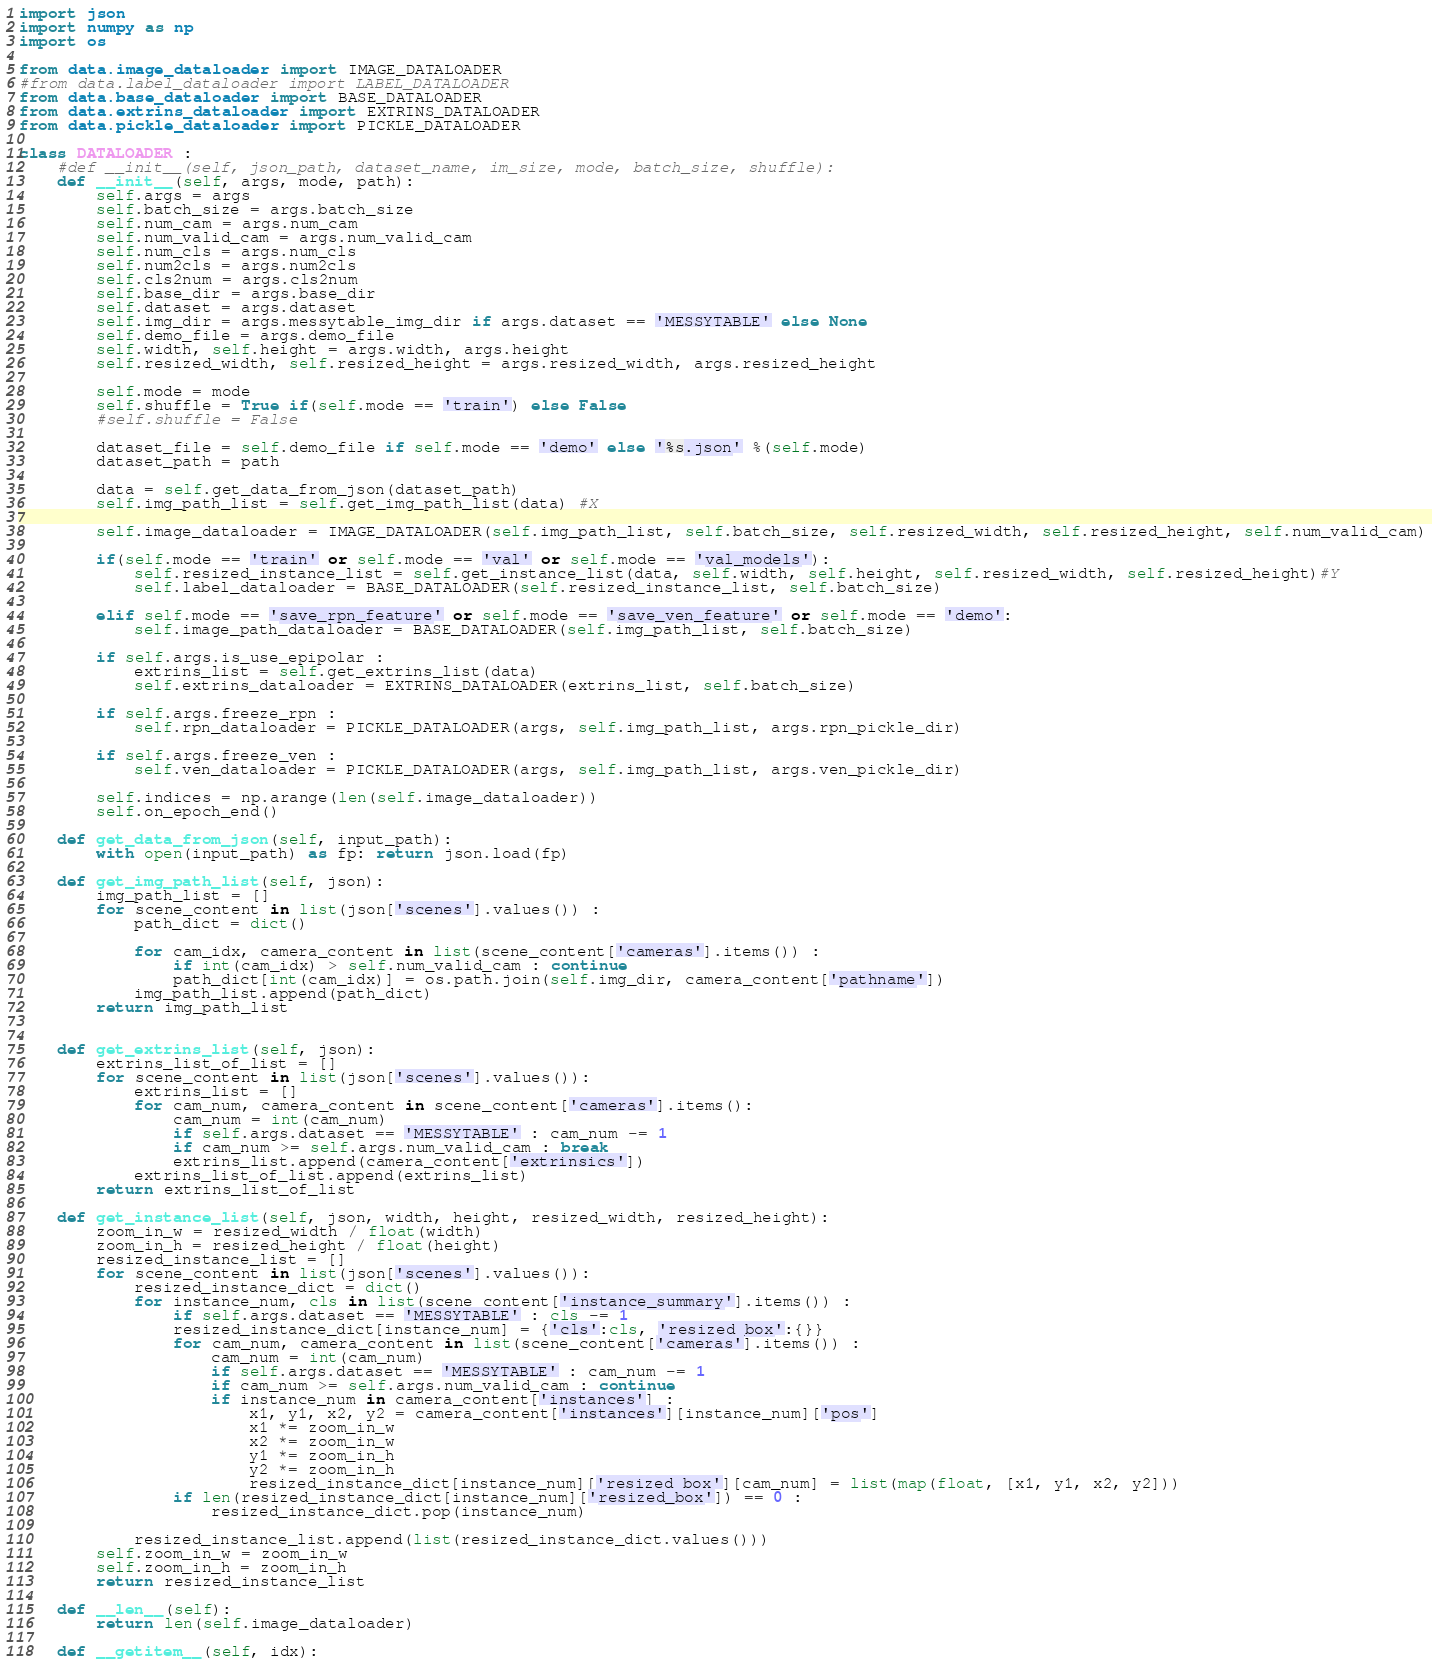<code> <loc_0><loc_0><loc_500><loc_500><_Python_>import json
import numpy as np
import os

from data.image_dataloader import IMAGE_DATALOADER
#from data.label_dataloader import LABEL_DATALOADER
from data.base_dataloader import BASE_DATALOADER
from data.extrins_dataloader import EXTRINS_DATALOADER
from data.pickle_dataloader import PICKLE_DATALOADER

class DATALOADER :
    #def __init__(self, json_path, dataset_name, im_size, mode, batch_size, shuffle):
    def __init__(self, args, mode, path):
        self.args = args
        self.batch_size = args.batch_size
        self.num_cam = args.num_cam
        self.num_valid_cam = args.num_valid_cam
        self.num_cls = args.num_cls
        self.num2cls = args.num2cls
        self.cls2num = args.cls2num
        self.base_dir = args.base_dir
        self.dataset = args.dataset
        self.img_dir = args.messytable_img_dir if args.dataset == 'MESSYTABLE' else None
        self.demo_file = args.demo_file
        self.width, self.height = args.width, args.height
        self.resized_width, self.resized_height = args.resized_width, args.resized_height

        self.mode = mode
        self.shuffle = True if(self.mode == 'train') else False
        #self.shuffle = False

        dataset_file = self.demo_file if self.mode == 'demo' else '%s.json' %(self.mode) 
        dataset_path = path 

        data = self.get_data_from_json(dataset_path)
        self.img_path_list = self.get_img_path_list(data) #X

        self.image_dataloader = IMAGE_DATALOADER(self.img_path_list, self.batch_size, self.resized_width, self.resized_height, self.num_valid_cam)

        if(self.mode == 'train' or self.mode == 'val' or self.mode == 'val_models'):
            self.resized_instance_list = self.get_instance_list(data, self.width, self.height, self.resized_width, self.resized_height)#Y
            self.label_dataloader = BASE_DATALOADER(self.resized_instance_list, self.batch_size)

        elif self.mode == 'save_rpn_feature' or self.mode == 'save_ven_feature' or self.mode == 'demo':
            self.image_path_dataloader = BASE_DATALOADER(self.img_path_list, self.batch_size)

        if self.args.is_use_epipolar : 
            extrins_list = self.get_extrins_list(data)
            self.extrins_dataloader = EXTRINS_DATALOADER(extrins_list, self.batch_size)

        if self.args.freeze_rpn :
            self.rpn_dataloader = PICKLE_DATALOADER(args, self.img_path_list, args.rpn_pickle_dir)

        if self.args.freeze_ven :
            self.ven_dataloader = PICKLE_DATALOADER(args, self.img_path_list, args.ven_pickle_dir)

        self.indices = np.arange(len(self.image_dataloader))
        self.on_epoch_end()

    def get_data_from_json(self, input_path):
        with open(input_path) as fp: return json.load(fp)

    def get_img_path_list(self, json):
        img_path_list = []
        for scene_content in list(json['scenes'].values()) :
            path_dict = dict()

            for cam_idx, camera_content in list(scene_content['cameras'].items()) :
                if int(cam_idx) > self.num_valid_cam : continue
                path_dict[int(cam_idx)] = os.path.join(self.img_dir, camera_content['pathname'])
            img_path_list.append(path_dict)
        return img_path_list


    def get_extrins_list(self, json):
        extrins_list_of_list = [] 
        for scene_content in list(json['scenes'].values()):
            extrins_list = []
            for cam_num, camera_content in scene_content['cameras'].items():
                cam_num = int(cam_num)
                if self.args.dataset == 'MESSYTABLE' : cam_num -= 1
                if cam_num >= self.args.num_valid_cam : break
                extrins_list.append(camera_content['extrinsics'])
            extrins_list_of_list.append(extrins_list)
        return extrins_list_of_list

    def get_instance_list(self, json, width, height, resized_width, resized_height):
        zoom_in_w = resized_width / float(width)
        zoom_in_h = resized_height / float(height)
        resized_instance_list = []
        for scene_content in list(json['scenes'].values()):
            resized_instance_dict = dict()
            for instance_num, cls in list(scene_content['instance_summary'].items()) :
                if self.args.dataset == 'MESSYTABLE' : cls -= 1
                resized_instance_dict[instance_num] = {'cls':cls, 'resized_box':{}}
                for cam_num, camera_content in list(scene_content['cameras'].items()) :
                    cam_num = int(cam_num)
                    if self.args.dataset == 'MESSYTABLE' : cam_num -= 1
                    if cam_num >= self.args.num_valid_cam : continue
                    if instance_num in camera_content['instances'] :
                        x1, y1, x2, y2 = camera_content['instances'][instance_num]['pos']
                        x1 *= zoom_in_w                
                        x2 *= zoom_in_w                
                        y1 *= zoom_in_h                
                        y2 *= zoom_in_h                
                        resized_instance_dict[instance_num]['resized_box'][cam_num] = list(map(float, [x1, y1, x2, y2]))
                if len(resized_instance_dict[instance_num]['resized_box']) == 0 :
                    resized_instance_dict.pop(instance_num)

            resized_instance_list.append(list(resized_instance_dict.values()))
        self.zoom_in_w = zoom_in_w
        self.zoom_in_h = zoom_in_h
        return resized_instance_list

    def __len__(self):
        return len(self.image_dataloader)

    def __getitem__(self, idx):</code> 